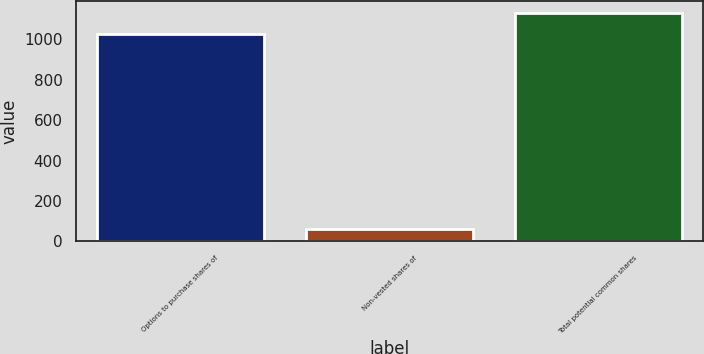Convert chart to OTSL. <chart><loc_0><loc_0><loc_500><loc_500><bar_chart><fcel>Options to purchase shares of<fcel>Non-vested shares of<fcel>Total potential common shares<nl><fcel>1029<fcel>60<fcel>1131.9<nl></chart> 